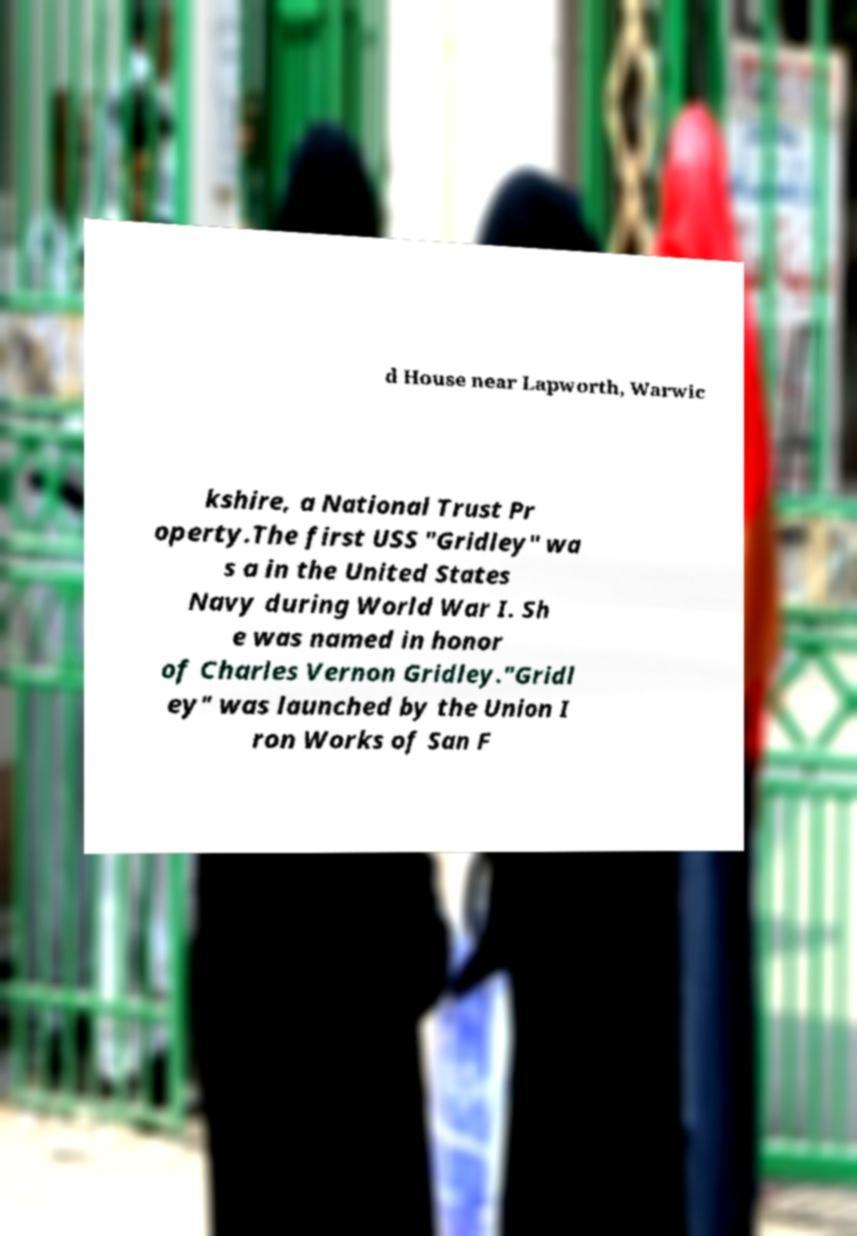For documentation purposes, I need the text within this image transcribed. Could you provide that? d House near Lapworth, Warwic kshire, a National Trust Pr operty.The first USS "Gridley" wa s a in the United States Navy during World War I. Sh e was named in honor of Charles Vernon Gridley."Gridl ey" was launched by the Union I ron Works of San F 